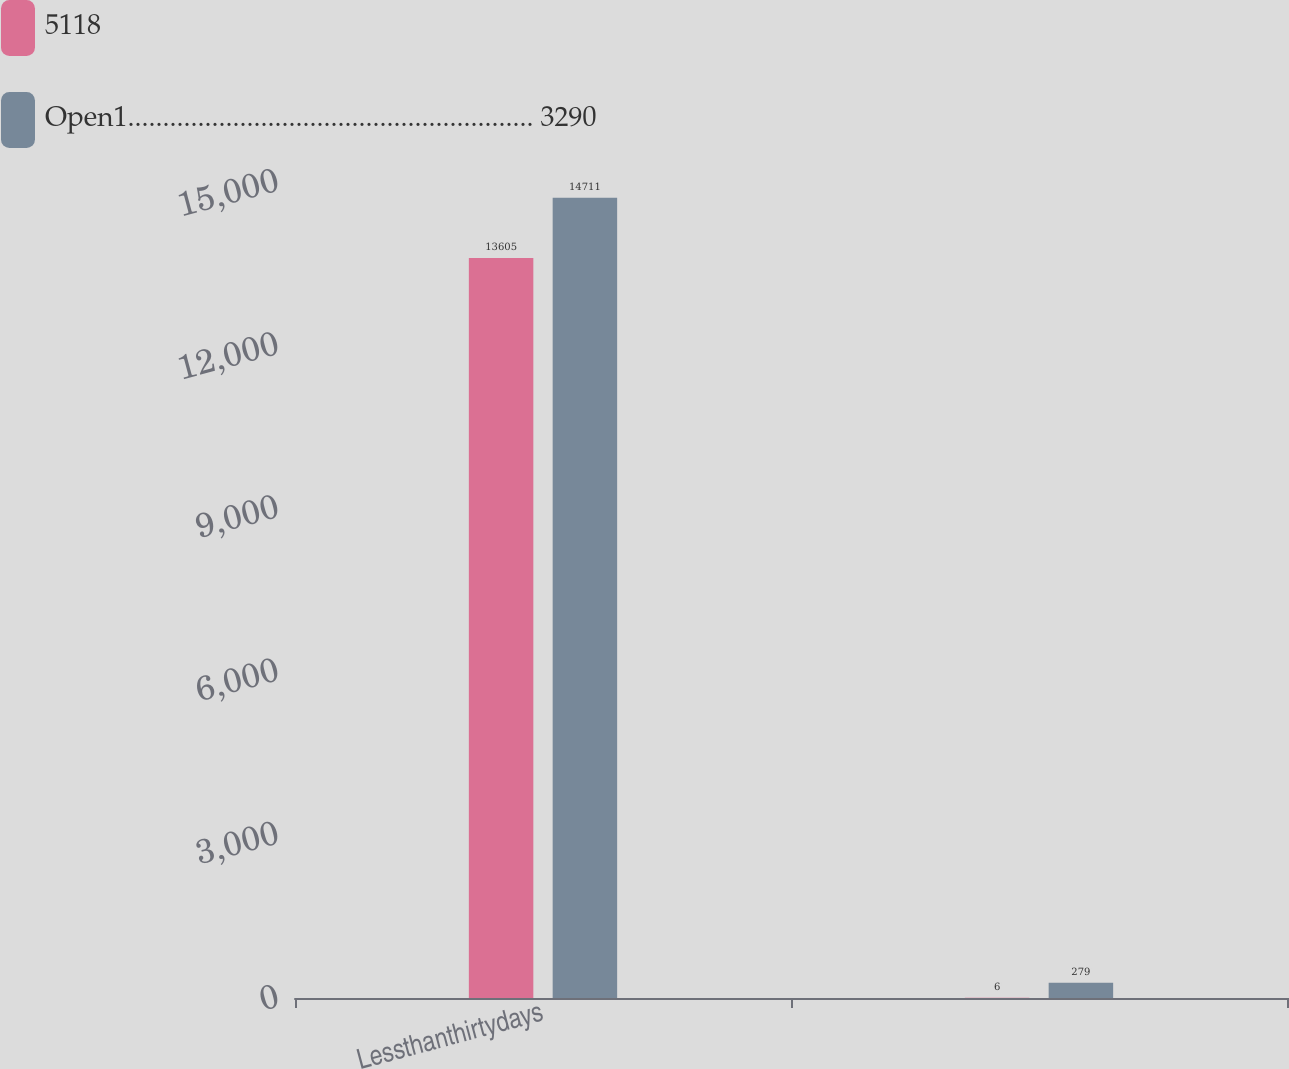Convert chart to OTSL. <chart><loc_0><loc_0><loc_500><loc_500><stacked_bar_chart><ecel><fcel>Lessthanthirtydays<fcel>Unnamed: 2<nl><fcel>5118<fcel>13605<fcel>6<nl><fcel>Open1.......................................................... 3290<fcel>14711<fcel>279<nl></chart> 